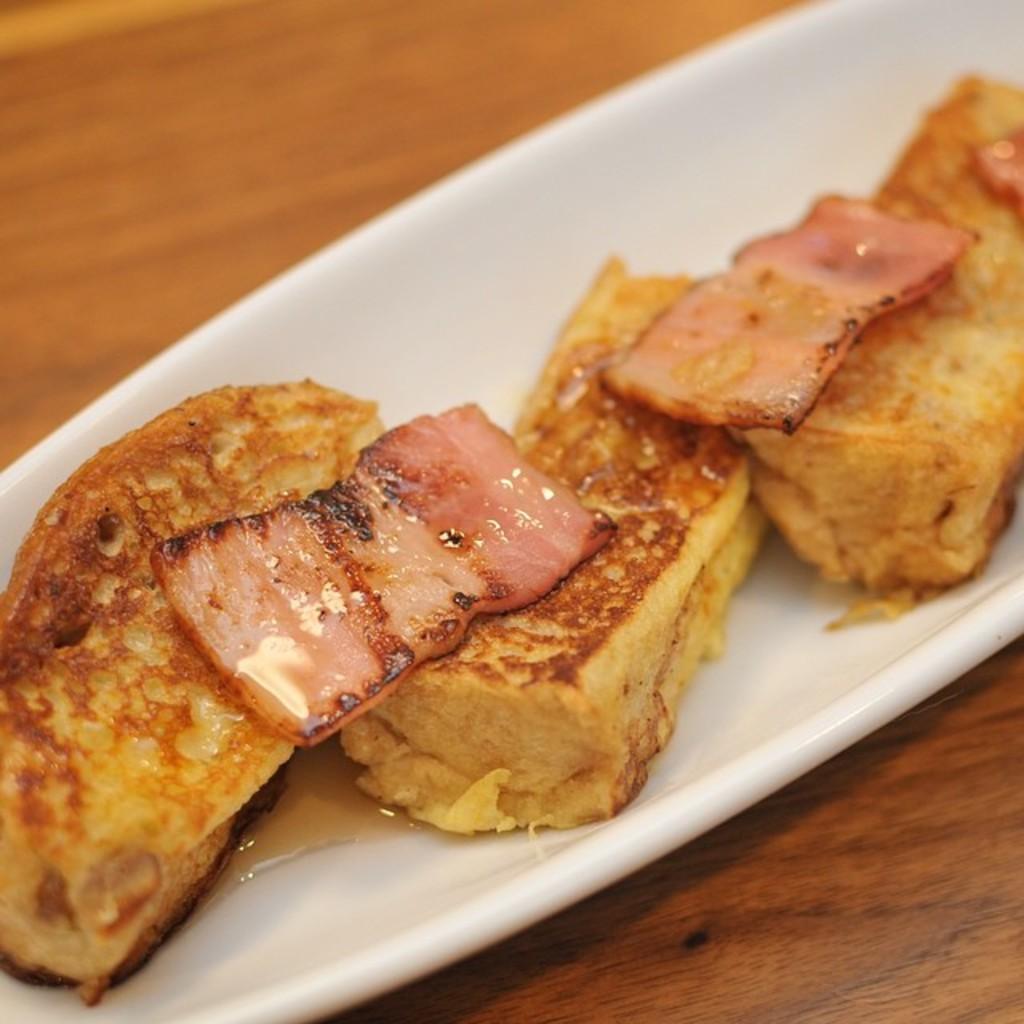How would you summarize this image in a sentence or two? Here I can see a bowl which consists of some food item. This bowl is placed on a table. 